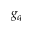Convert formula to latex. <formula><loc_0><loc_0><loc_500><loc_500>g _ { q }</formula> 